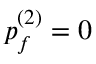Convert formula to latex. <formula><loc_0><loc_0><loc_500><loc_500>p _ { f } ^ { ( 2 ) } = 0</formula> 